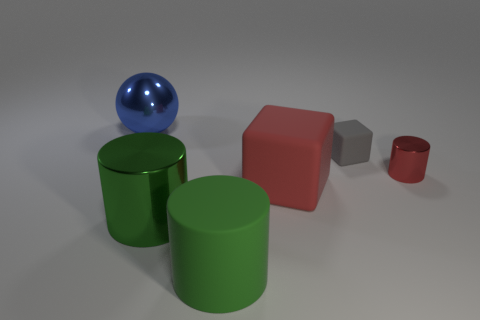There is a small gray rubber object; what number of objects are on the left side of it?
Your answer should be very brief. 4. Does the blue metal thing behind the large red cube have the same size as the metal cylinder that is in front of the small red thing?
Provide a short and direct response. Yes. What number of other objects are the same size as the gray matte object?
Offer a terse response. 1. There is a cube that is to the right of the red object in front of the metal cylinder that is right of the big block; what is it made of?
Offer a terse response. Rubber. Does the red matte block have the same size as the metal cylinder in front of the tiny red shiny cylinder?
Your answer should be very brief. Yes. What size is the metallic thing that is both in front of the big blue shiny thing and left of the gray rubber cube?
Offer a very short reply. Large. Are there any blocks of the same color as the small metallic cylinder?
Ensure brevity in your answer.  Yes. There is a object in front of the large green metal cylinder on the left side of the green matte thing; what color is it?
Ensure brevity in your answer.  Green. Are there fewer small cylinders that are on the left side of the large metallic ball than tiny things that are right of the gray cube?
Give a very brief answer. Yes. Is the metal sphere the same size as the red matte block?
Your answer should be compact. Yes. 